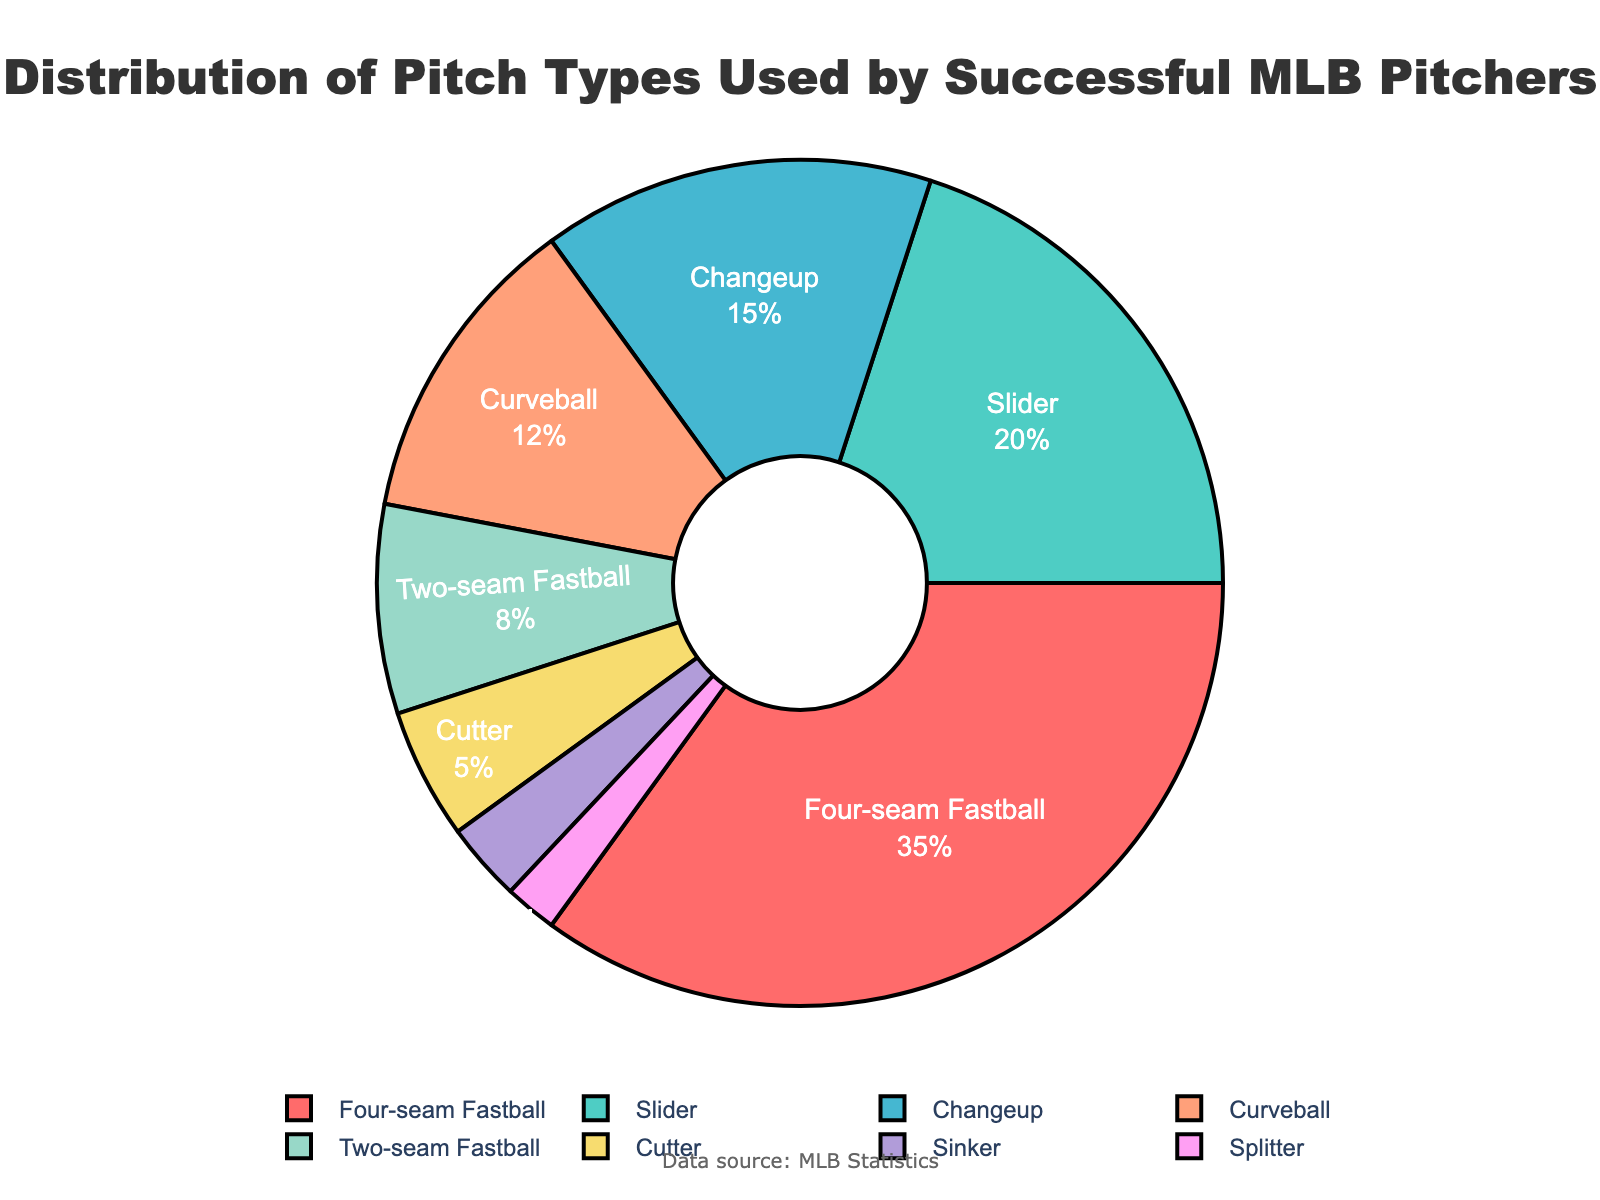Which pitch type is used the most by successful MLB pitchers? The figure shows that the Four-seam Fastball segment is the largest in the pie chart.
Answer: Four-seam Fastball What is the total percentage of breaking balls (Slider and Curveball)? The Slider is 20%, and the Curveball is 12%. Adding these together gives 20% + 12% = 32%.
Answer: 32% Which pitch type has the smallest percentage of usage? The pie chart shows that the smallest segment is the Splitter.
Answer: Splitter How much more prevalent is the Four-seam Fastball compared to the Changeup? The Four-seam Fastball is 35% and the Changeup is 15%. The difference is 35% - 15% = 20%.
Answer: 20% What is the combined percentage of fastball types (Four-seam Fastball, Two-seam Fastball, and Cutter)? Four-seam Fastball is 35%, Two-seam Fastball is 8%, and Cutter is 5%. Adding these percentages together: 35% + 8% + 5% = 48%.
Answer: 48% Which color represents the Slider on the pie chart? The color coding in the pie chart shows that the Slider is represented by a greenish-blue segment.
Answer: Greenish-blue If you were to remove the percentage of sinkers, what would be the new total percentage of remaining pitches? The Sinker represents 3%. Removing this from 100% results in 100% - 3% = 97%.
Answer: 97% Compare the usage of Curveball and Cutter. Which one is used more, and by how much? The Curveball is used 12% and the Cutter is used 5%. The Curveball is used 12% - 5% = 7% more than the Cutter.
Answer: Curveball by 7% Which pitch type is closest in usage percentage to the Slider? The Slider usage is 20%, and the Changeup usage is 15%. The Changeup, with a 5% difference from the Slider, is the closest.
Answer: Changeup What is the difference in percentage between the two least used pitch types? The Sinker's usage is 3%, and the Splitter's usage is 2%. The difference is 3% - 2% = 1%.
Answer: 1% 